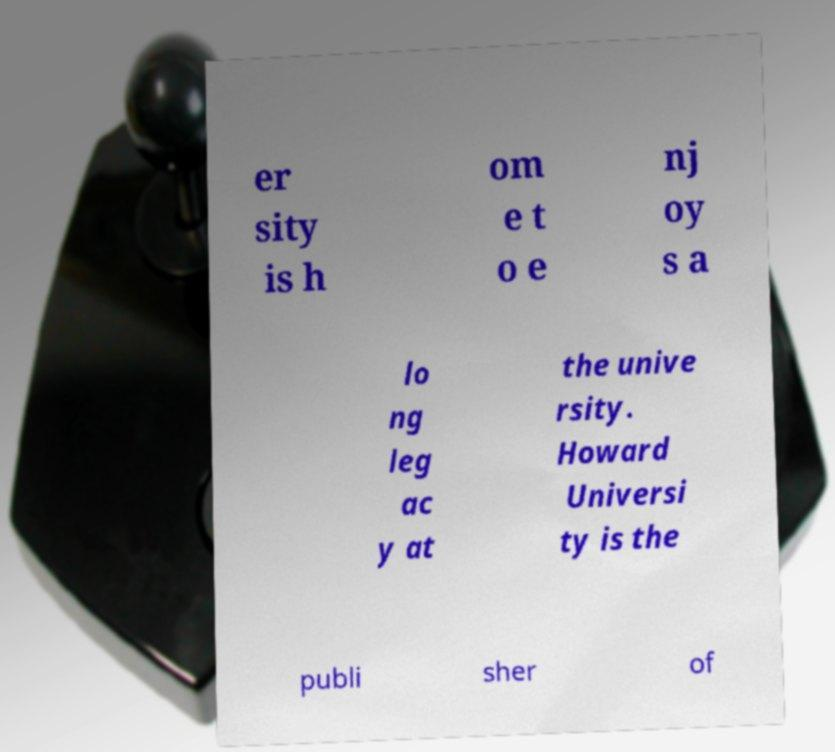What messages or text are displayed in this image? I need them in a readable, typed format. er sity is h om e t o e nj oy s a lo ng leg ac y at the unive rsity. Howard Universi ty is the publi sher of 